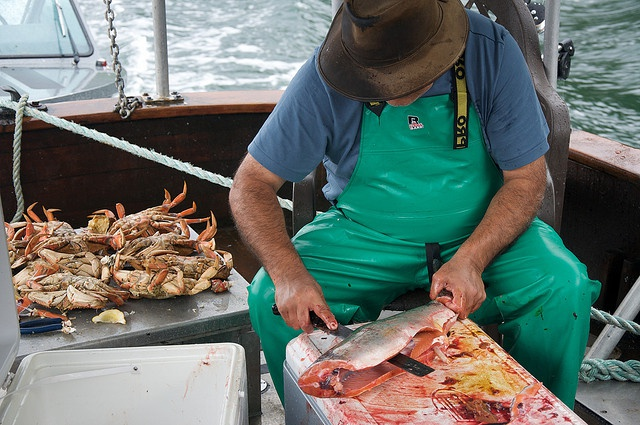Describe the objects in this image and their specific colors. I can see people in white, teal, black, and brown tones, boat in white, lightgray, lightblue, and darkgray tones, and knife in white, black, gray, maroon, and brown tones in this image. 